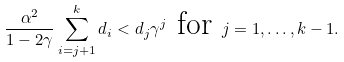Convert formula to latex. <formula><loc_0><loc_0><loc_500><loc_500>\frac { \alpha ^ { 2 } } { 1 - 2 \gamma } \sum _ { i = j + 1 } ^ { k } d _ { i } < d _ { j } \gamma ^ { j } \text { for } j = 1 , \dots , k - 1 .</formula> 